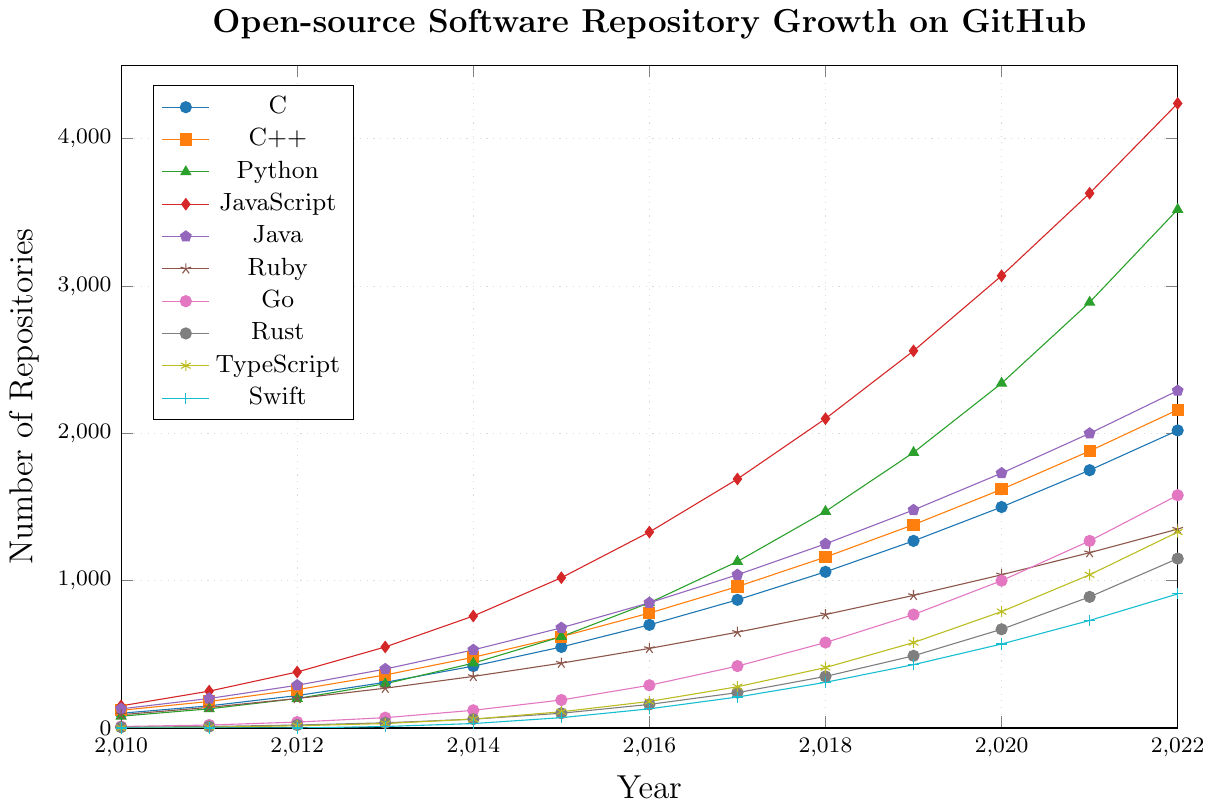Which programming language had the highest number of repositories in 2022? In 2022, JavaScript had the highest number of repositories. By referring to the coordinates for each programming language, JavaScript reaches 4240, which is the highest point.
Answer: JavaScript How many more repositories did Python have compared to Ruby in 2020? In 2020, Python had 2340 repositories and Ruby had 1040 repositories. The difference between them is 2340 - 1040 = 1300.
Answer: 1300 Which language showed the steepest growth from 2018 to 2022? To determine the steepest growth, we calculate the difference in the number of repositories for each language between 2018 and 2022. JavaScript had the largest increase: 4240 - 2100 = 2140.
Answer: JavaScript Which languages had no repositories in 2010 but had over 1000 repositories by 2022? Comparing the data points, TypeScript and Swift had zero repositories in 2010, and by 2022, both reached 1330 and 910 repositories respectively.
Answer: TypeScript, Swift In which year did Go surpass 1000 repositories? By checking the growth of Go yearly, Go reached 1000 repositories in 2020.
Answer: 2020 What was the average number of repositories across all languages in 2015? Adding the number of repositories for all languages in 2015: 550 + 620 + 620 + 1020 + 680 + 440 + 190 + 100 + 110 + 70 = 4400. The average is 4400 / 10 = 440.
Answer: 440 Which programming language had the lowest number of repositories in 2017? Rust had the lowest number of repositories in 2017 at 240, as evident from the chart.
Answer: Rust What was the increase in the number of repositories for JavaScript from 2010 to 2012? In 2010, JavaScript had 150 repositories. By 2012, it had 380 repositories. The increase is 380 - 150 = 230.
Answer: 230 Did TypeScript have more repositories than Go in 2018? In 2018, TypeScript had 410 repositories, while Go had 580 repositories. Go had more repositories than TypeScript.
Answer: No Which language experienced consistent growth every year without any decline? Observing the lines, several languages such as JavaScript, Python, Java, Ruby, Go, Rust, TypeScript, and Swift showed consistent year-on-year growth without any decline.
Answer: JavaScript, Python, Java, Ruby, Go, Rust, TypeScript, Swift 